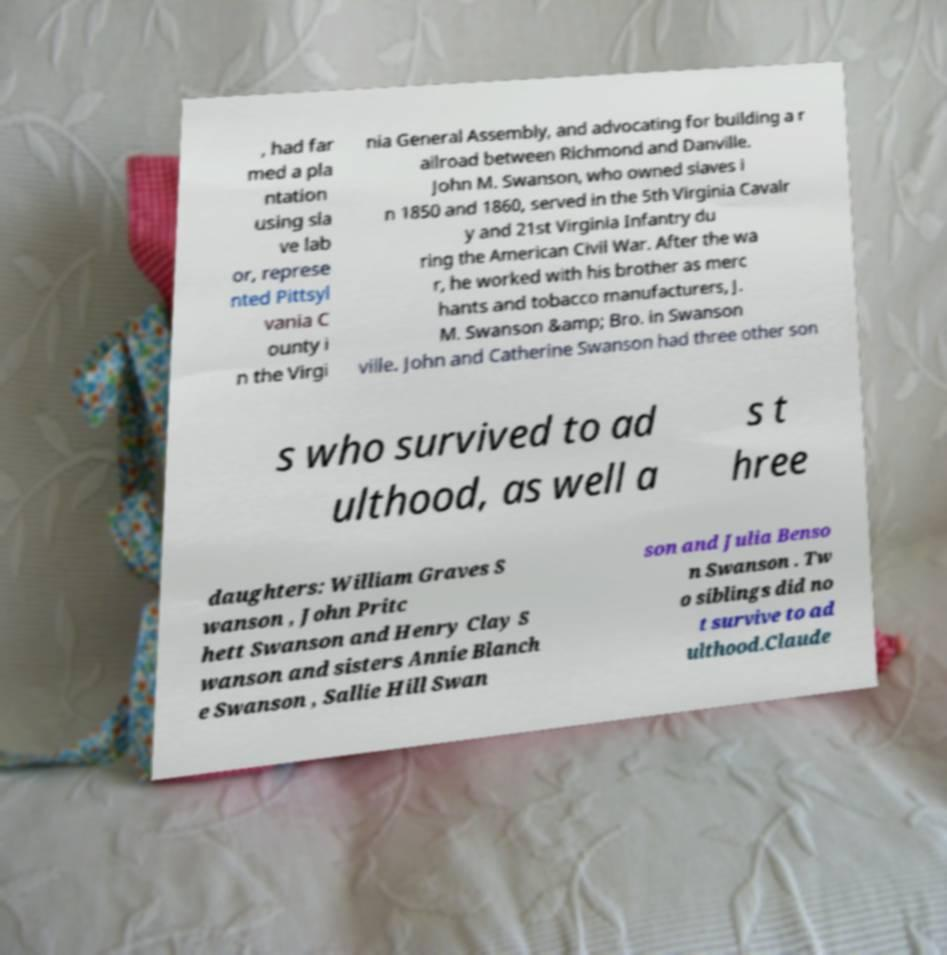Please identify and transcribe the text found in this image. , had far med a pla ntation using sla ve lab or, represe nted Pittsyl vania C ounty i n the Virgi nia General Assembly, and advocating for building a r ailroad between Richmond and Danville. John M. Swanson, who owned slaves i n 1850 and 1860, served in the 5th Virginia Cavalr y and 21st Virginia Infantry du ring the American Civil War. After the wa r, he worked with his brother as merc hants and tobacco manufacturers, J. M. Swanson &amp; Bro. in Swanson ville. John and Catherine Swanson had three other son s who survived to ad ulthood, as well a s t hree daughters: William Graves S wanson , John Pritc hett Swanson and Henry Clay S wanson and sisters Annie Blanch e Swanson , Sallie Hill Swan son and Julia Benso n Swanson . Tw o siblings did no t survive to ad ulthood.Claude 